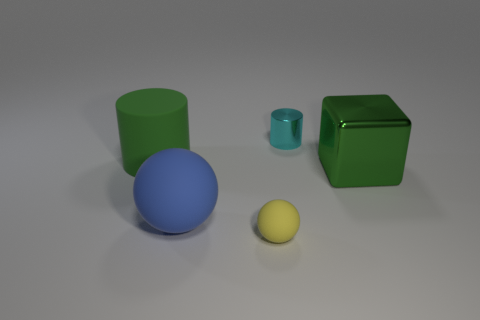Add 5 big green shiny objects. How many objects exist? 10 Subtract all balls. How many objects are left? 3 Subtract all small balls. Subtract all small objects. How many objects are left? 2 Add 2 small cyan metallic cylinders. How many small cyan metallic cylinders are left? 3 Add 2 red spheres. How many red spheres exist? 2 Subtract 1 yellow spheres. How many objects are left? 4 